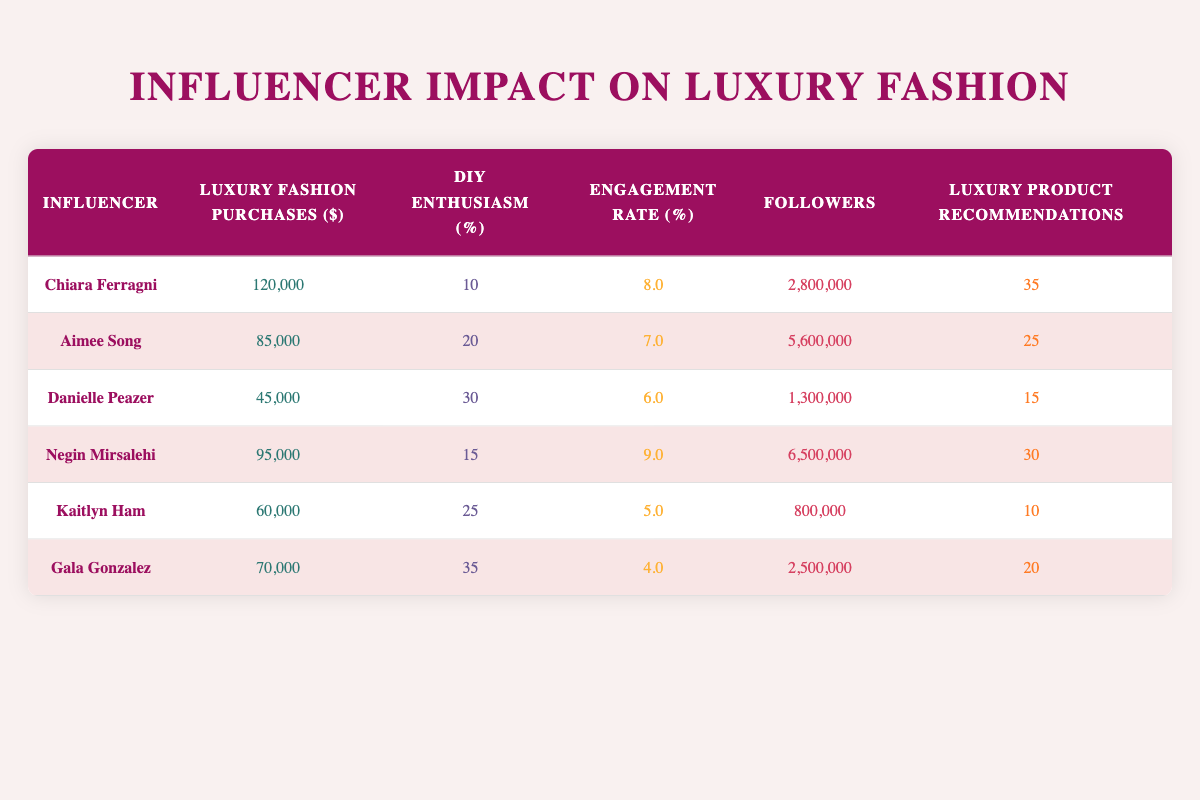What's the total number of luxury fashion purchases made by the influencers? To find the total, I need to sum up the luxury fashion purchases across all influencers: 120000 + 85000 + 45000 + 95000 + 60000 + 70000 = 450000.
Answer: 450000 Which influencer has the highest engagement rate? By comparing the engagement rates of each influencer, Chiara Ferragni has an engagement rate of 8.0, Negin Mirsalehi has 9.0, Aimee Song has 7.0, Danielle Peazer has 6.0, Kaitlyn Ham has 5.0, and Gala Gonzalez has 4.0. Negin Mirsalehi has the highest engagement rate of 9.0.
Answer: Negin Mirsalehi Is there any influencer whose DIY enthusiasm is greater than 30%? Checking the DIY enthusiasm percentages, Danielle Peazer has 30%, Gala Gonzalez has 35%, and  all other percentages are lower. Therefore, yes, both Danielle Peazer and Gala Gonzalez have DIY enthusiasm greater than 30%.
Answer: Yes What is the average number of followers among the influencers? The total number of followers is the sum of each: 2800000 + 5600000 + 1300000 + 6500000 + 800000 + 2500000 = 20500000. Since there are 6 influencers, the average followers is 20500000 / 6 = 3416666.67, which rounds to approximately 3416667.
Answer: 3416667 Is there a correlation between luxury product recommendations and luxury fashion purchases? By analyzing, Chiara Ferragni with 120000 purchases makes 35 recommendations, and Negin Mirsalehi with 95000 purchases makes 30 recommendations, showcasing a potential trend. However, no definitive correlation can be drawn without statistical analysis, often showing that higher purchases align with more recommendations.
Answer: Not directly determinable from the data What percentage of DIY enthusiasm does Aimee Song have compared to the highest in the table? Aimee Song has a DIY enthusiasm of 20%. The highest enthusiasm is 35% from Gala Gonzalez, so to find the percentage of Aimee Song compared to Gala Gonzalez, (20 / 35) * 100 = 57.14%.
Answer: 57.14% Which influencer has the lowest luxury fashion purchases? Upon reviewing the luxury fashion purchases, Danielle Peazer has the lowest purchase amount at 45000.
Answer: Danielle Peazer Is Negin Mirsalehi promoting the most luxury products? Comparing the luxury product recommendations, Chiara Ferragni has 35 recommendations, Negin Mirsalehi has 30. Therefore, the statement is false as Chiara Ferragni promotes the most.
Answer: No 